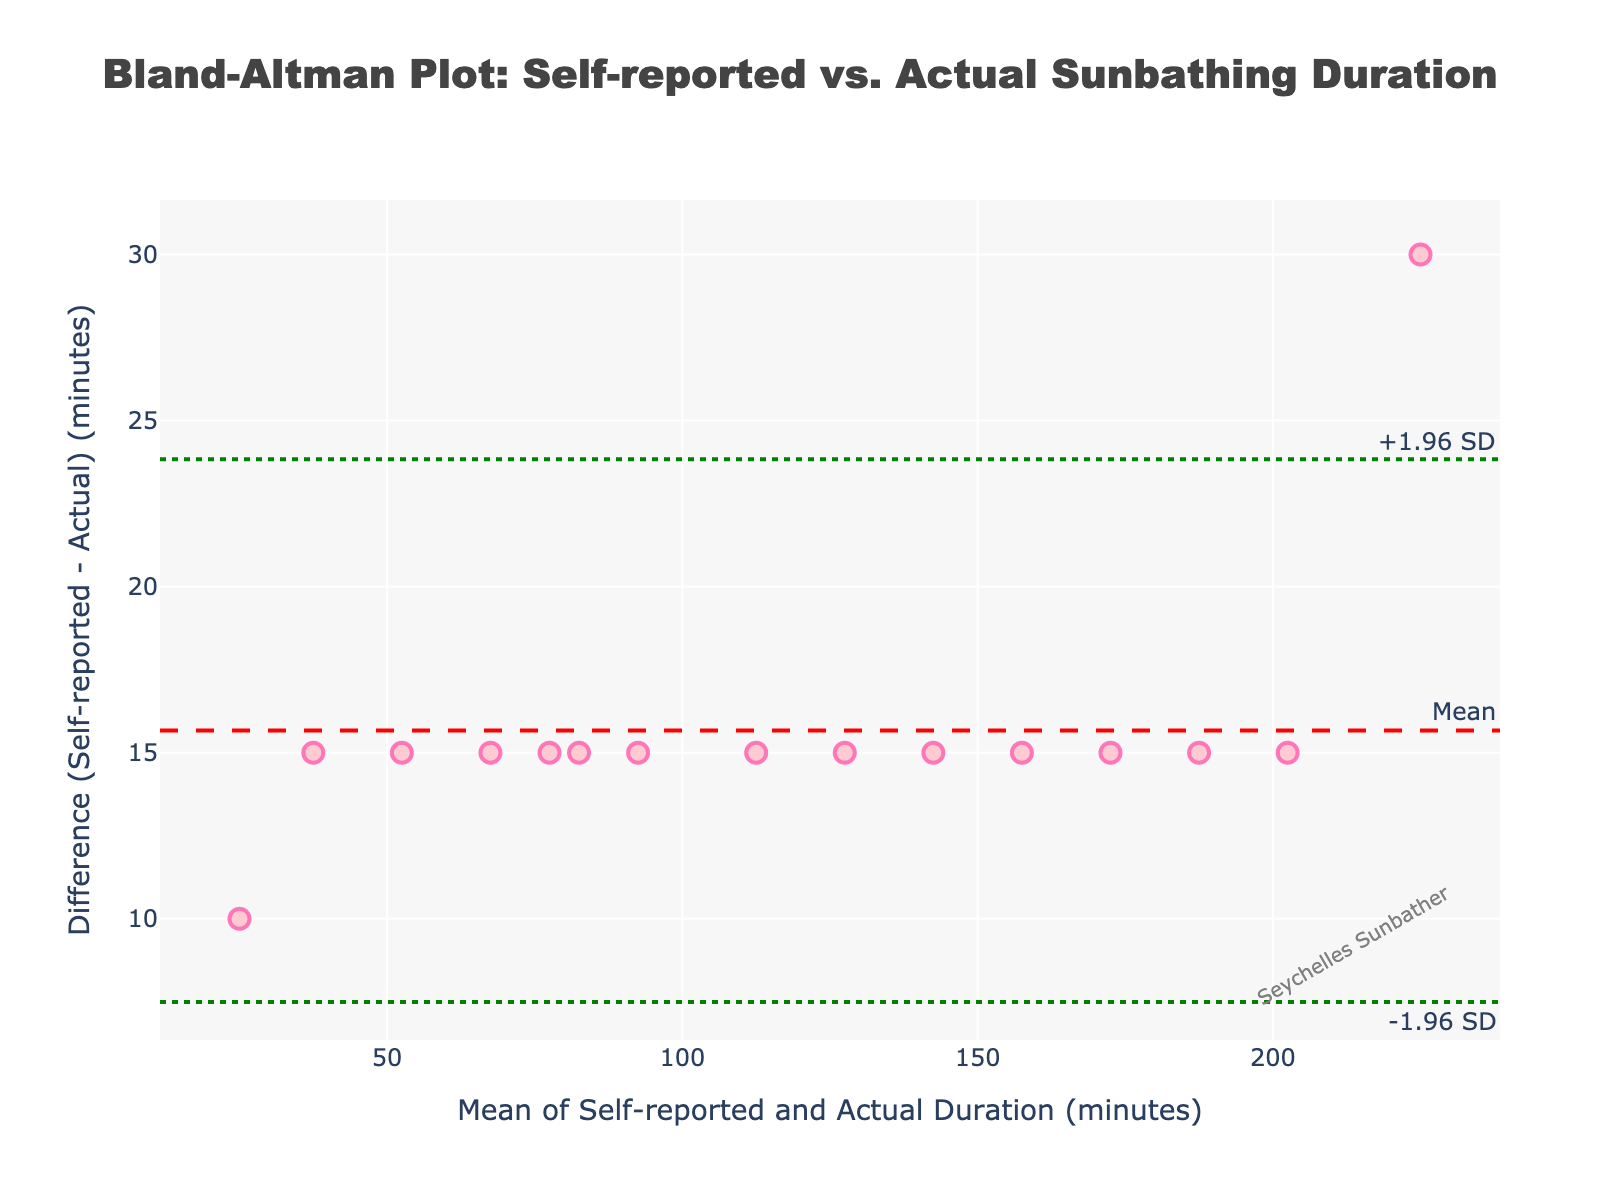how many data points are plotted in the Bland-Altman plot? Examine the figure closely. Each data point corresponds to a dot on the plot. Count the number of dots.
Answer: 15 What is the title of the figure? The figure's title is prominently displayed at the top center of the plot.
Answer: Bland-Altman Plot: Self-reported vs. Actual Sunbathing Duration What does the y-axis represent? Look at the label on the y-axis on the left side of the plot. It indicates what is being measured on this axis.
Answer: Difference (Self-reported - Actual) (minutes) Where is the mean difference line located? The mean difference line is indicated by the red dash line with an annotation marking "Mean". Find where this line intersects the y-axis.
Answer: Around 15 minutes What are the upper and lower limits of agreement in the plot? Identify the green dotted lines with annotations "+1.96 SD" and "-1.96 SD". These lines represent the upper and lower limits of agreement, respectively. Check their y-axis values.
Answer: Around 64.44 and -34.44 minutes Is there a watermark on the plot? If yes, what does it say? Look for any text annotation that does not relate to the data. Watermarks are usually placed in less prominent areas of the plot.
Answer: Yes, "Seychelles Sunbather" What's the average value of the mean on the x-axis? The x-axis represents the mean of the self-reported and actual durations. Calculate the mean of these mean values by summing them up and dividing by the total number of data points. (240+195+270+105+285+450+50+405+135+255+185+75+375+155+315)/15.
Answer: 248 minutes Do most points lie within the limits of agreement? Examine the distribution of the data points in relation to the green dotted lines. Count the total points and those within the limits.
Answer: Yes What is the largest difference recorded between self-reported and actual duration? Check the y-axis values to identify the maximum positive or negative difference. The largest point will correspond to this value.
Answer: Around 30 minutes 